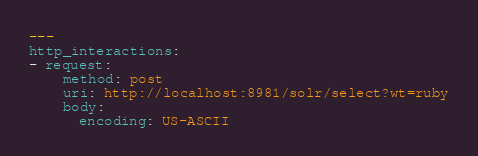Convert code to text. <code><loc_0><loc_0><loc_500><loc_500><_YAML_>---
http_interactions:
- request:
    method: post
    uri: http://localhost:8981/solr/select?wt=ruby
    body:
      encoding: US-ASCII</code> 